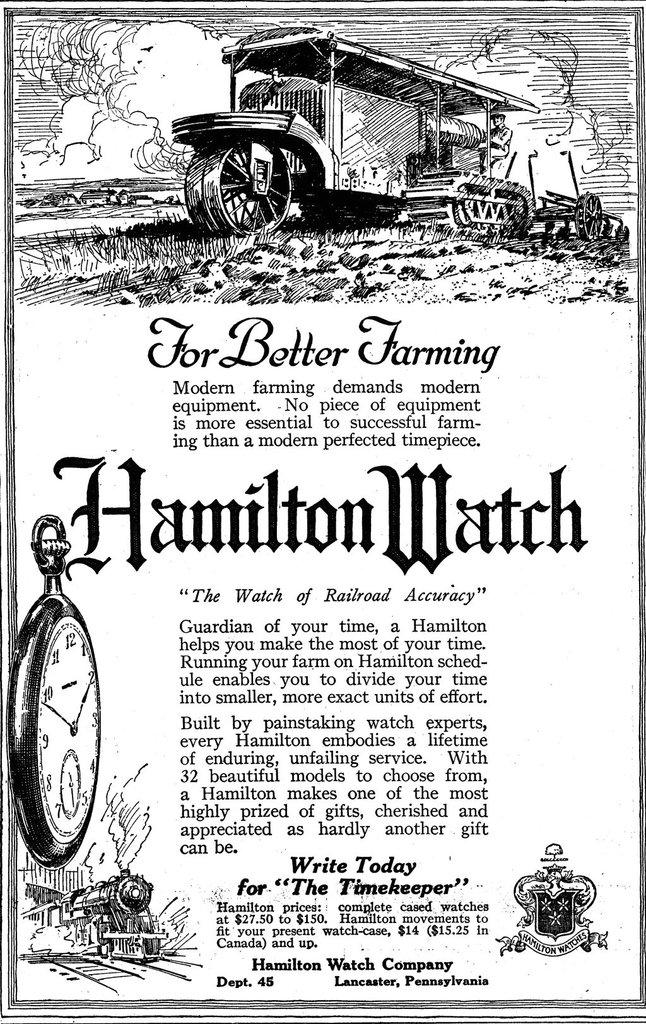<image>
Render a clear and concise summary of the photo. An illustration with an article called for better farming. 